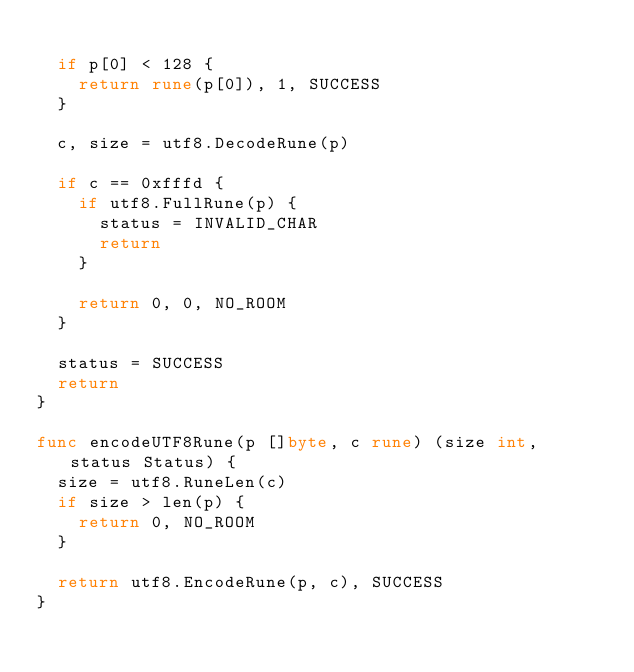Convert code to text. <code><loc_0><loc_0><loc_500><loc_500><_Go_>
	if p[0] < 128 {
		return rune(p[0]), 1, SUCCESS
	}

	c, size = utf8.DecodeRune(p)

	if c == 0xfffd {
		if utf8.FullRune(p) {
			status = INVALID_CHAR
			return
		}

		return 0, 0, NO_ROOM
	}

	status = SUCCESS
	return
}

func encodeUTF8Rune(p []byte, c rune) (size int, status Status) {
	size = utf8.RuneLen(c)
	if size > len(p) {
		return 0, NO_ROOM
	}

	return utf8.EncodeRune(p, c), SUCCESS
}
</code> 